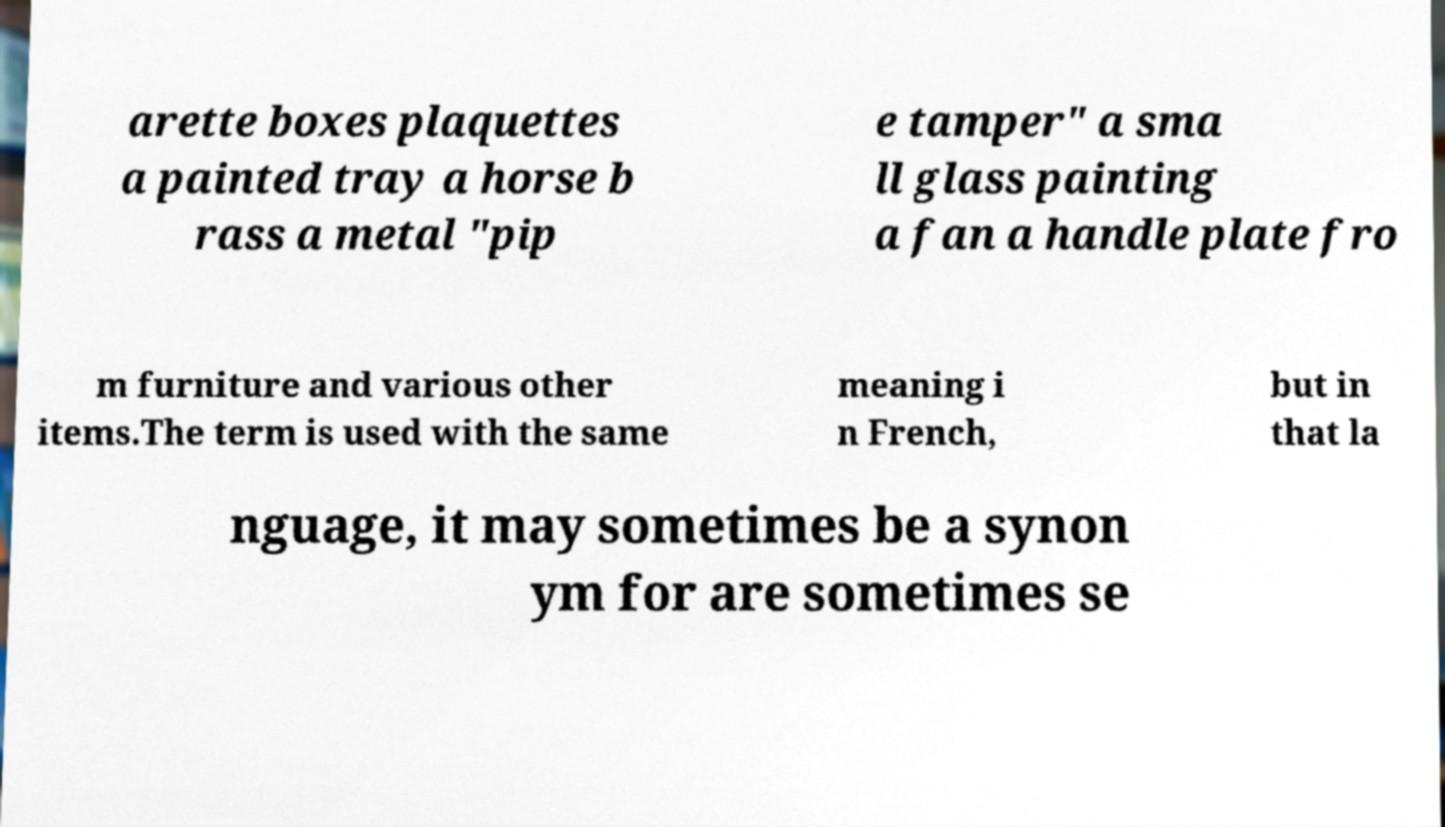Can you read and provide the text displayed in the image?This photo seems to have some interesting text. Can you extract and type it out for me? arette boxes plaquettes a painted tray a horse b rass a metal "pip e tamper" a sma ll glass painting a fan a handle plate fro m furniture and various other items.The term is used with the same meaning i n French, but in that la nguage, it may sometimes be a synon ym for are sometimes se 